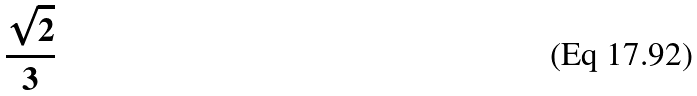<formula> <loc_0><loc_0><loc_500><loc_500>\frac { \sqrt { 2 } } { 3 }</formula> 